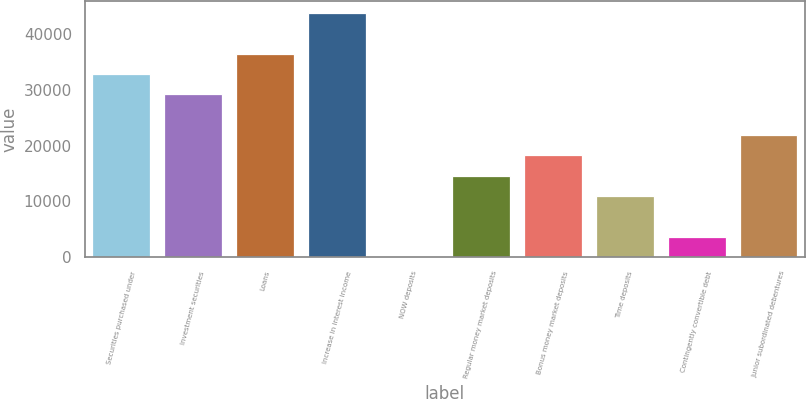Convert chart to OTSL. <chart><loc_0><loc_0><loc_500><loc_500><bar_chart><fcel>Securities purchased under<fcel>Investment securities<fcel>Loans<fcel>Increase in interest income<fcel>NOW deposits<fcel>Regular money market deposits<fcel>Bonus money market deposits<fcel>Time deposits<fcel>Contingently convertible debt<fcel>Junior subordinated debentures<nl><fcel>32864.5<fcel>29213<fcel>36516<fcel>43819<fcel>1<fcel>14607<fcel>18258.5<fcel>10955.5<fcel>3652.5<fcel>21910<nl></chart> 